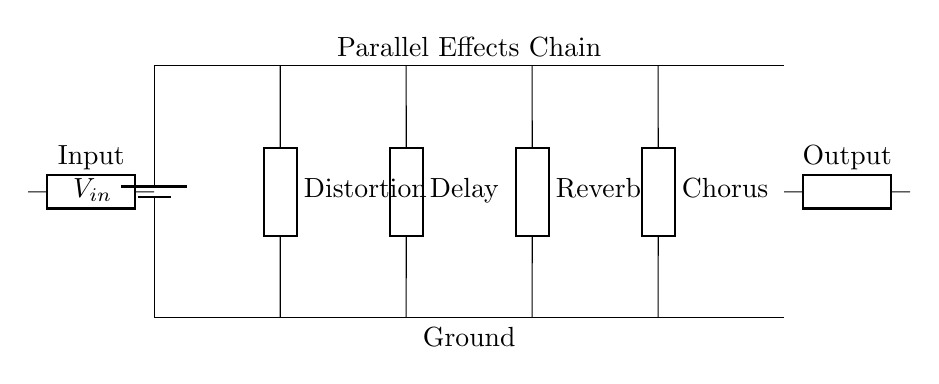What components are in the circuit? The components in this circuit include a battery for power, an input, four effect pedals (Distortion, Delay, Reverb, Chorus), and an output.
Answer: Battery, Input, Distortion, Delay, Reverb, Chorus, Output How many effect pedals are used in the circuit? There are four effect pedals present in the circuit, which are Distortion, Delay, Reverb, and Chorus.
Answer: Four What is the function of the generic symbol on the output? The generic symbol on the output represents the final output of the effects chain, which sends the processed signal to the next stage in the audio path.
Answer: Output signal What is the arrangement of the effect pedals in the circuit? The arrangement of the effect pedals is in parallel, meaning each pedal receives the same input signal simultaneously without affecting each other's operation.
Answer: Parallel Which effect pedal is positioned first in the circuit? The Distortion pedal is positioned first since it is the first effect connected to the power line following the input.
Answer: Distortion What determines the signal paths in this parallel circuit? In this parallel circuit, each effect pedal has its own independent signal path that branches off from the main line, allowing the simultaneous use of all pedals.
Answer: Independent paths How does this circuit type affect the sound? The parallel arrangement allows for all effects to blend together without altering each other, producing a combined sound that retains characteristics of all effects used.
Answer: Blended sound 